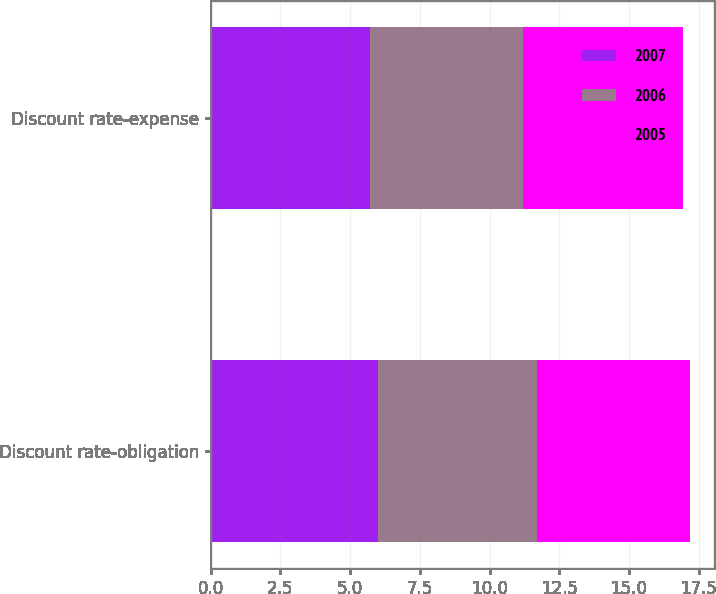<chart> <loc_0><loc_0><loc_500><loc_500><stacked_bar_chart><ecel><fcel>Discount rate-obligation<fcel>Discount rate-expense<nl><fcel>2007<fcel>6<fcel>5.7<nl><fcel>2006<fcel>5.7<fcel>5.5<nl><fcel>2005<fcel>5.5<fcel>5.75<nl></chart> 